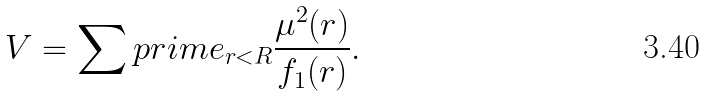Convert formula to latex. <formula><loc_0><loc_0><loc_500><loc_500>V = \sum p r i m e _ { r < R } \frac { \mu ^ { 2 } ( r ) } { f _ { 1 } ( r ) } .</formula> 